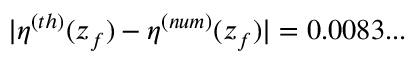Convert formula to latex. <formula><loc_0><loc_0><loc_500><loc_500>| \eta ^ { ( t h ) } ( z _ { f } ) - \eta ^ { ( n u m ) } ( z _ { f } ) | = 0 . 0 0 8 3 \dots</formula> 